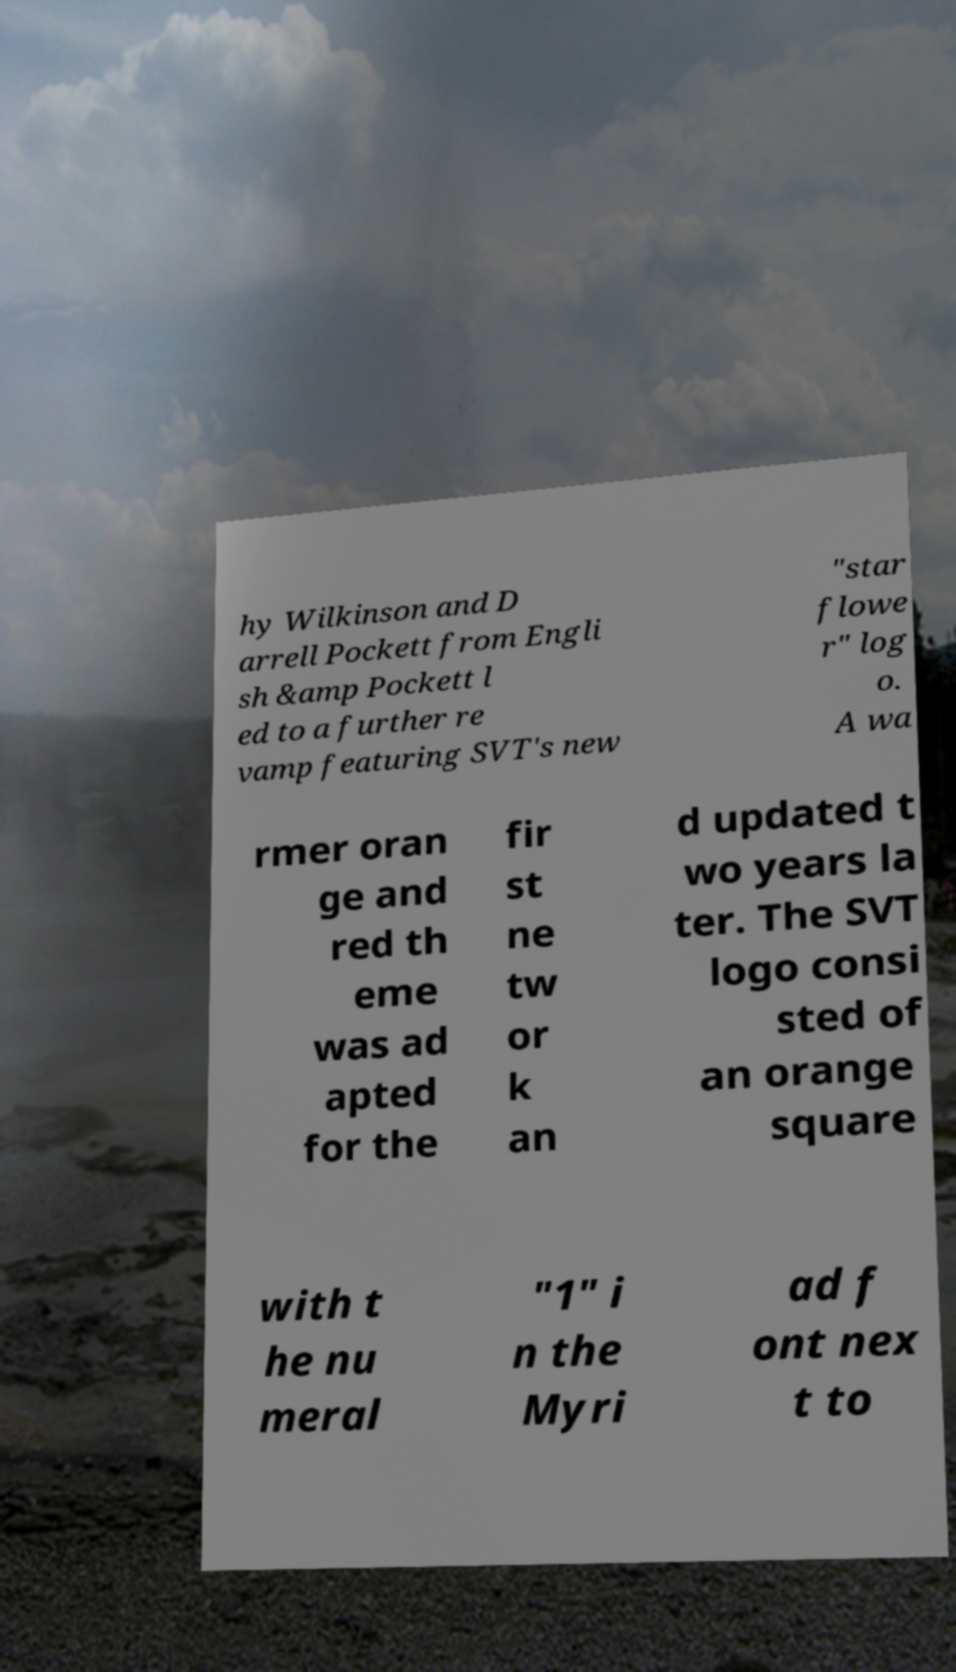Please read and relay the text visible in this image. What does it say? hy Wilkinson and D arrell Pockett from Engli sh &amp Pockett l ed to a further re vamp featuring SVT's new "star flowe r" log o. A wa rmer oran ge and red th eme was ad apted for the fir st ne tw or k an d updated t wo years la ter. The SVT logo consi sted of an orange square with t he nu meral "1" i n the Myri ad f ont nex t to 